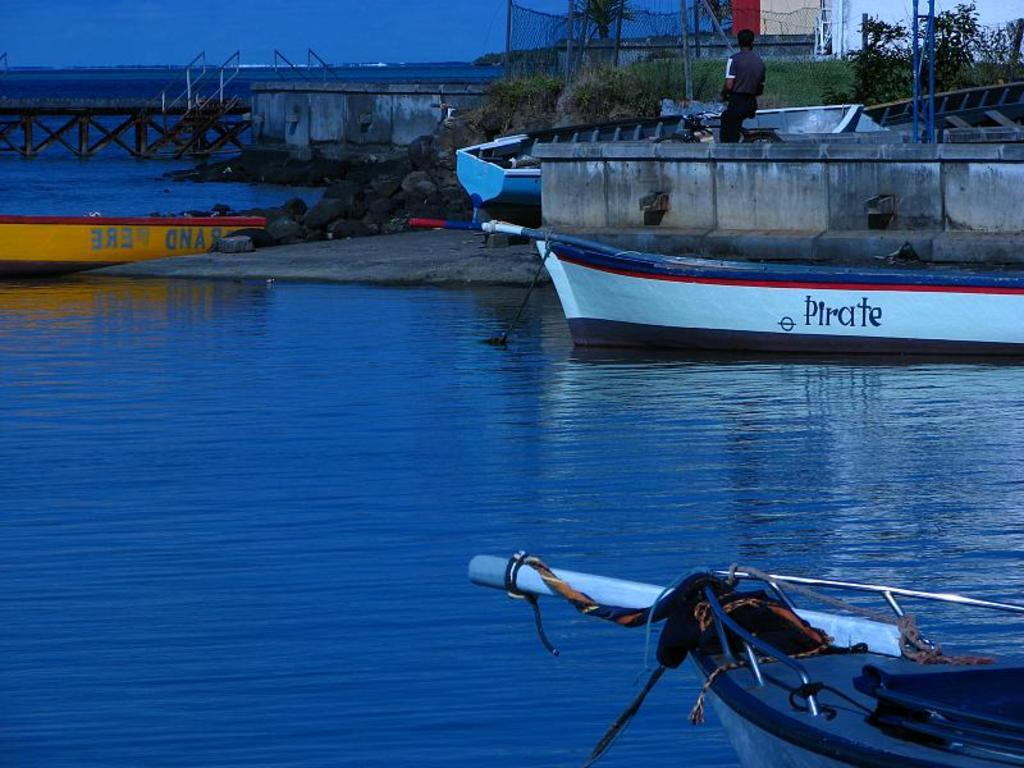What type of vehicles can be seen in the image? There are boats in the image. What is the primary element in which the boats are situated? There is water visible in the image. What type of structure is present in the image? There is a bridge in the image. What type of vegetation is present in the image? There are trees in the image. Can you describe the man in the image? There is a man standing in the image. What type of terrain is visible in the image? There is grass in the image. What type of building is present in the image? There is a house in the image. Where is the hose located in the image? There is no hose present in the image. What color is the man's stomach in the image? The image does not show the man's stomach, so it cannot be determined. 